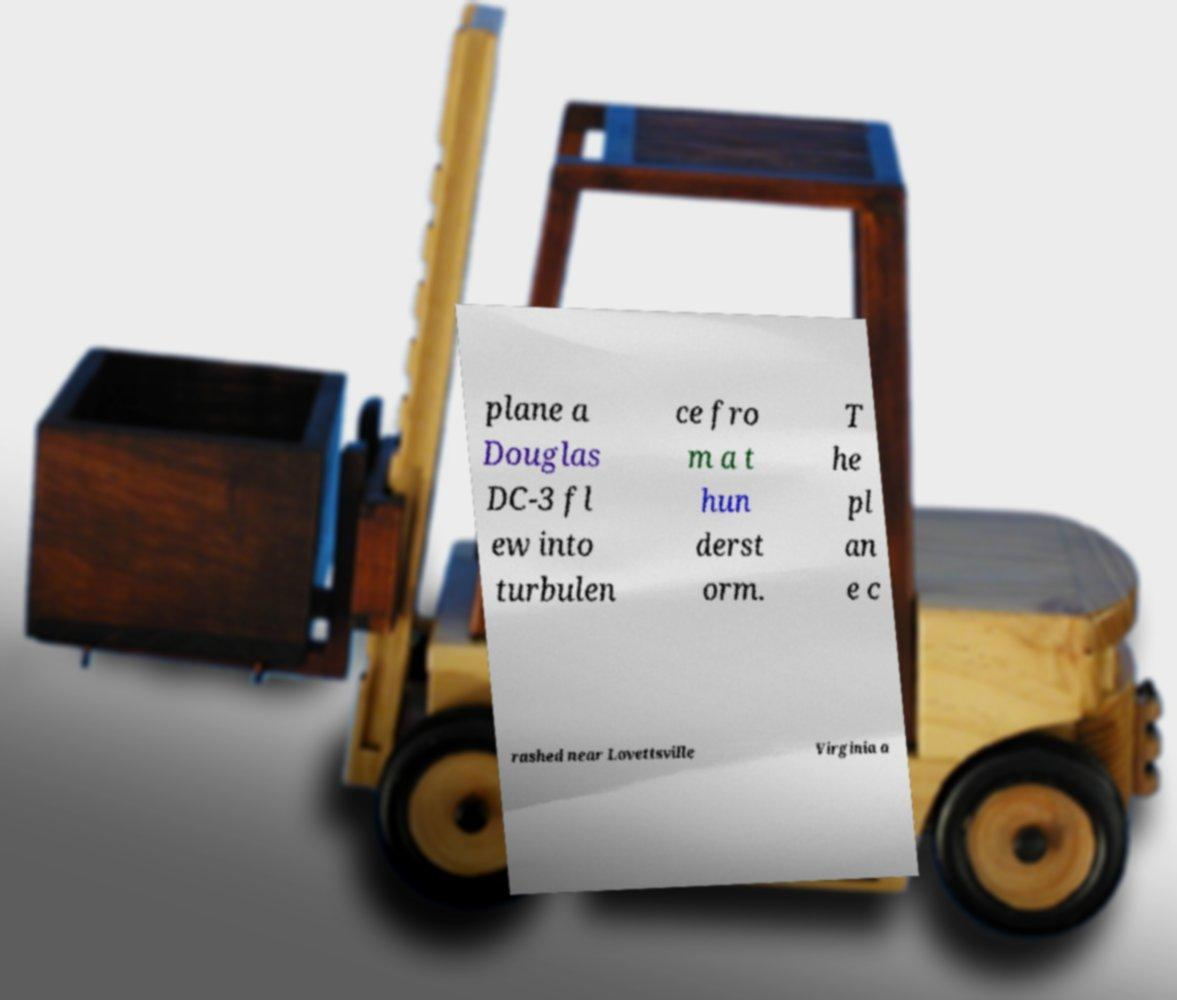Can you accurately transcribe the text from the provided image for me? plane a Douglas DC-3 fl ew into turbulen ce fro m a t hun derst orm. T he pl an e c rashed near Lovettsville Virginia a 